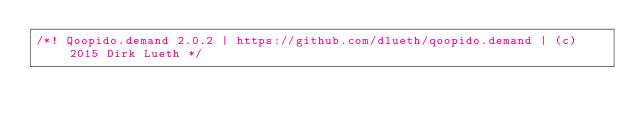Convert code to text. <code><loc_0><loc_0><loc_500><loc_500><_JavaScript_>/*! Qoopido.demand 2.0.2 | https://github.com/dlueth/qoopido.demand | (c) 2015 Dirk Lueth */</code> 